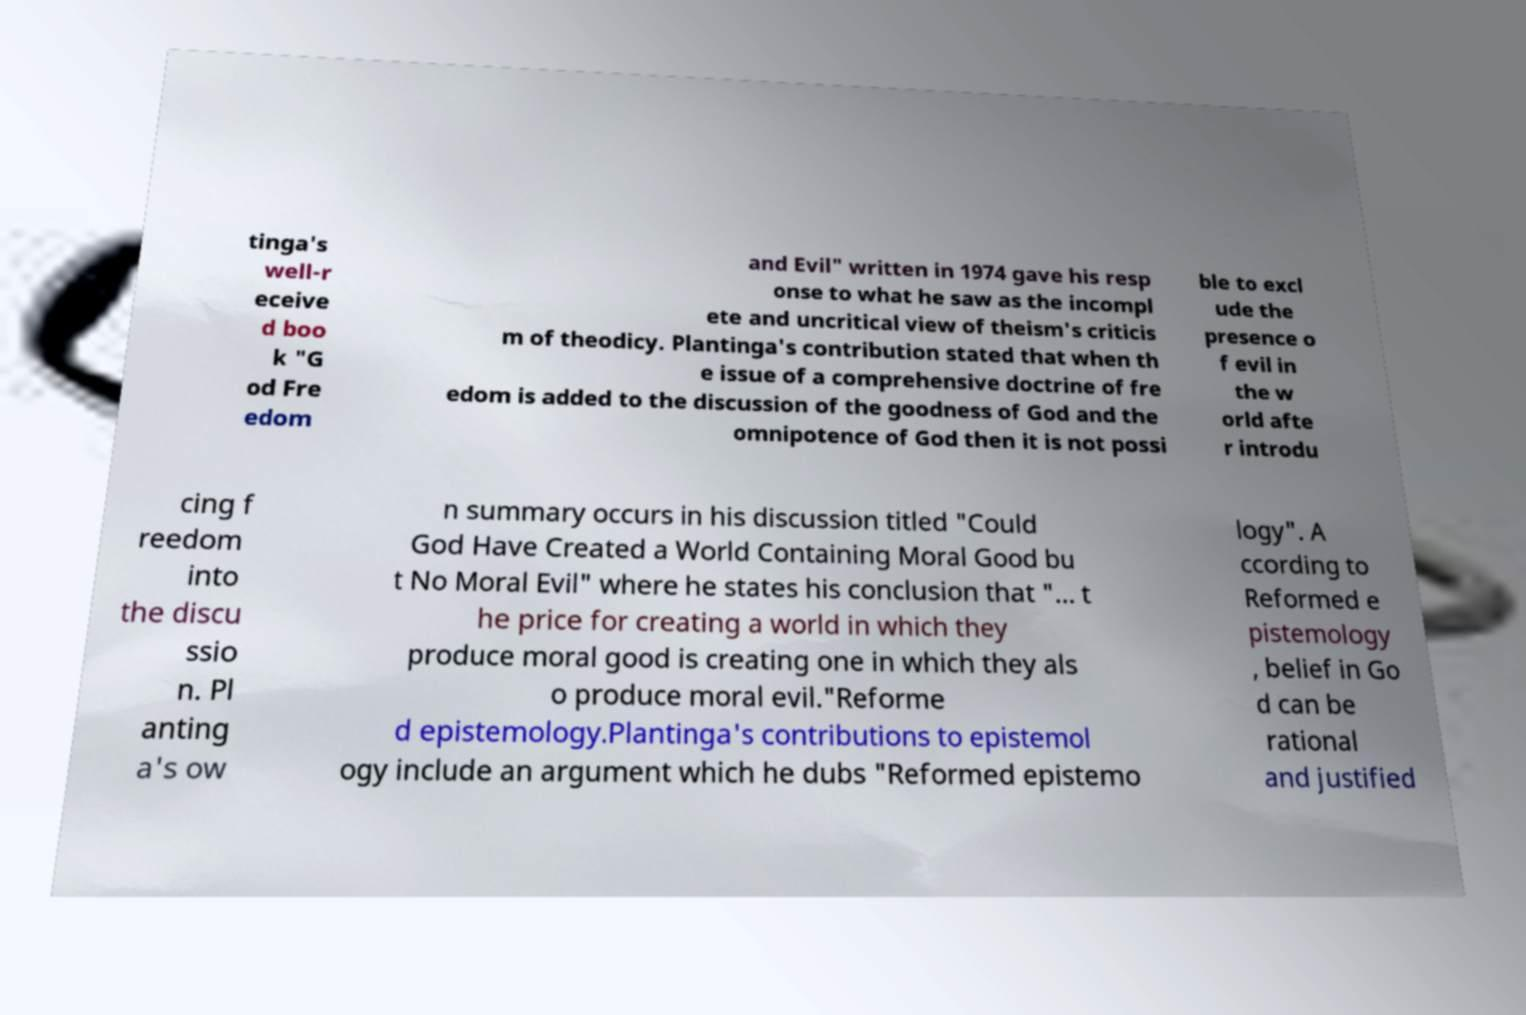There's text embedded in this image that I need extracted. Can you transcribe it verbatim? tinga's well-r eceive d boo k "G od Fre edom and Evil" written in 1974 gave his resp onse to what he saw as the incompl ete and uncritical view of theism's criticis m of theodicy. Plantinga's contribution stated that when th e issue of a comprehensive doctrine of fre edom is added to the discussion of the goodness of God and the omnipotence of God then it is not possi ble to excl ude the presence o f evil in the w orld afte r introdu cing f reedom into the discu ssio n. Pl anting a's ow n summary occurs in his discussion titled "Could God Have Created a World Containing Moral Good bu t No Moral Evil" where he states his conclusion that "... t he price for creating a world in which they produce moral good is creating one in which they als o produce moral evil."Reforme d epistemology.Plantinga's contributions to epistemol ogy include an argument which he dubs "Reformed epistemo logy". A ccording to Reformed e pistemology , belief in Go d can be rational and justified 